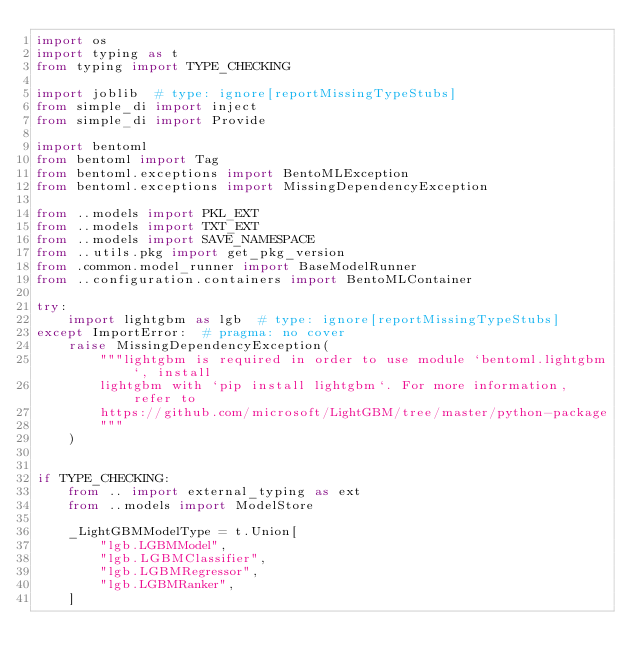<code> <loc_0><loc_0><loc_500><loc_500><_Python_>import os
import typing as t
from typing import TYPE_CHECKING

import joblib  # type: ignore[reportMissingTypeStubs]
from simple_di import inject
from simple_di import Provide

import bentoml
from bentoml import Tag
from bentoml.exceptions import BentoMLException
from bentoml.exceptions import MissingDependencyException

from ..models import PKL_EXT
from ..models import TXT_EXT
from ..models import SAVE_NAMESPACE
from ..utils.pkg import get_pkg_version
from .common.model_runner import BaseModelRunner
from ..configuration.containers import BentoMLContainer

try:
    import lightgbm as lgb  # type: ignore[reportMissingTypeStubs]
except ImportError:  # pragma: no cover
    raise MissingDependencyException(
        """lightgbm is required in order to use module `bentoml.lightgbm`, install
        lightgbm with `pip install lightgbm`. For more information, refer to
        https://github.com/microsoft/LightGBM/tree/master/python-package
        """
    )


if TYPE_CHECKING:
    from .. import external_typing as ext
    from ..models import ModelStore

    _LightGBMModelType = t.Union[
        "lgb.LGBMModel",
        "lgb.LGBMClassifier",
        "lgb.LGBMRegressor",
        "lgb.LGBMRanker",
    ]
</code> 